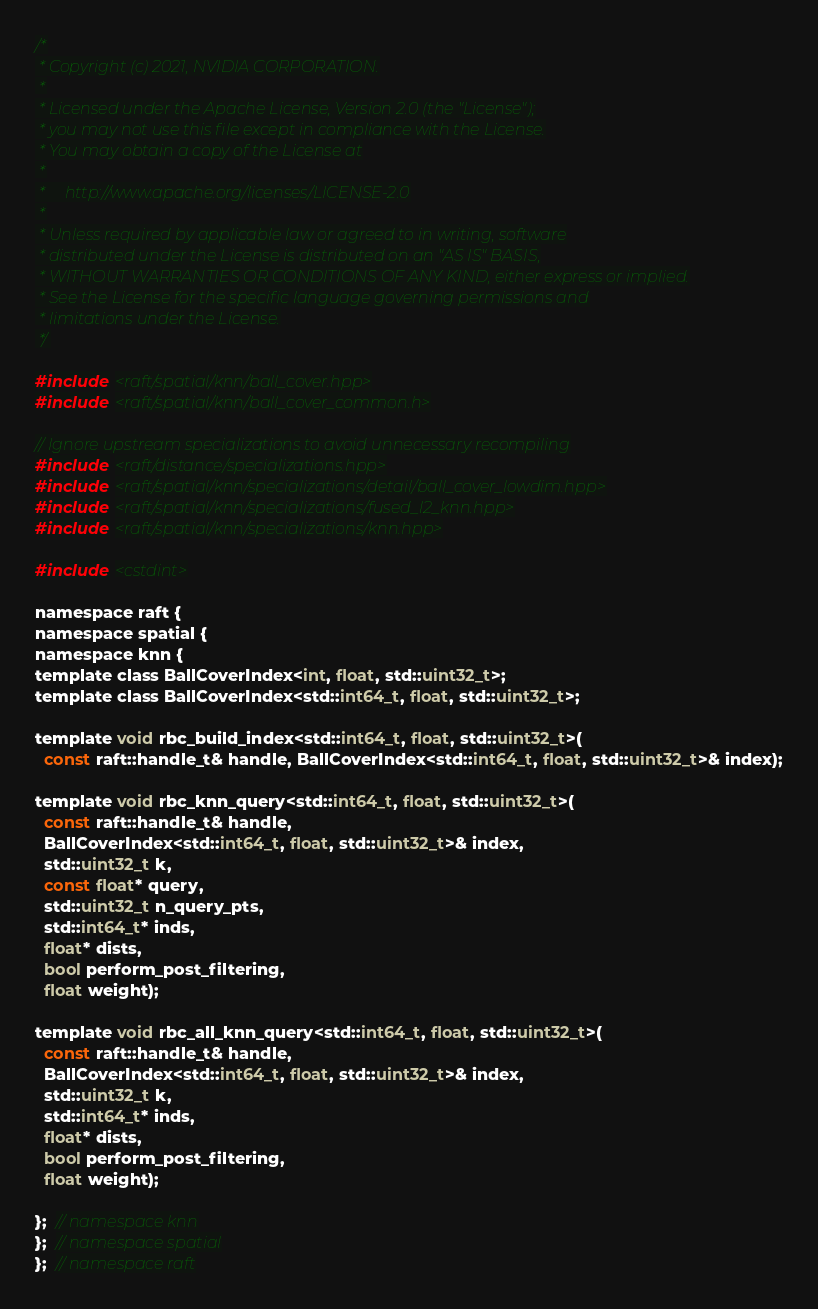<code> <loc_0><loc_0><loc_500><loc_500><_Cuda_>/*
 * Copyright (c) 2021, NVIDIA CORPORATION.
 *
 * Licensed under the Apache License, Version 2.0 (the "License");
 * you may not use this file except in compliance with the License.
 * You may obtain a copy of the License at
 *
 *     http://www.apache.org/licenses/LICENSE-2.0
 *
 * Unless required by applicable law or agreed to in writing, software
 * distributed under the License is distributed on an "AS IS" BASIS,
 * WITHOUT WARRANTIES OR CONDITIONS OF ANY KIND, either express or implied.
 * See the License for the specific language governing permissions and
 * limitations under the License.
 */

#include <raft/spatial/knn/ball_cover.hpp>
#include <raft/spatial/knn/ball_cover_common.h>

// Ignore upstream specializations to avoid unnecessary recompiling
#include <raft/distance/specializations.hpp>
#include <raft/spatial/knn/specializations/detail/ball_cover_lowdim.hpp>
#include <raft/spatial/knn/specializations/fused_l2_knn.hpp>
#include <raft/spatial/knn/specializations/knn.hpp>

#include <cstdint>

namespace raft {
namespace spatial {
namespace knn {
template class BallCoverIndex<int, float, std::uint32_t>;
template class BallCoverIndex<std::int64_t, float, std::uint32_t>;

template void rbc_build_index<std::int64_t, float, std::uint32_t>(
  const raft::handle_t& handle, BallCoverIndex<std::int64_t, float, std::uint32_t>& index);

template void rbc_knn_query<std::int64_t, float, std::uint32_t>(
  const raft::handle_t& handle,
  BallCoverIndex<std::int64_t, float, std::uint32_t>& index,
  std::uint32_t k,
  const float* query,
  std::uint32_t n_query_pts,
  std::int64_t* inds,
  float* dists,
  bool perform_post_filtering,
  float weight);

template void rbc_all_knn_query<std::int64_t, float, std::uint32_t>(
  const raft::handle_t& handle,
  BallCoverIndex<std::int64_t, float, std::uint32_t>& index,
  std::uint32_t k,
  std::int64_t* inds,
  float* dists,
  bool perform_post_filtering,
  float weight);

};  // namespace knn
};  // namespace spatial
};  // namespace raft
</code> 